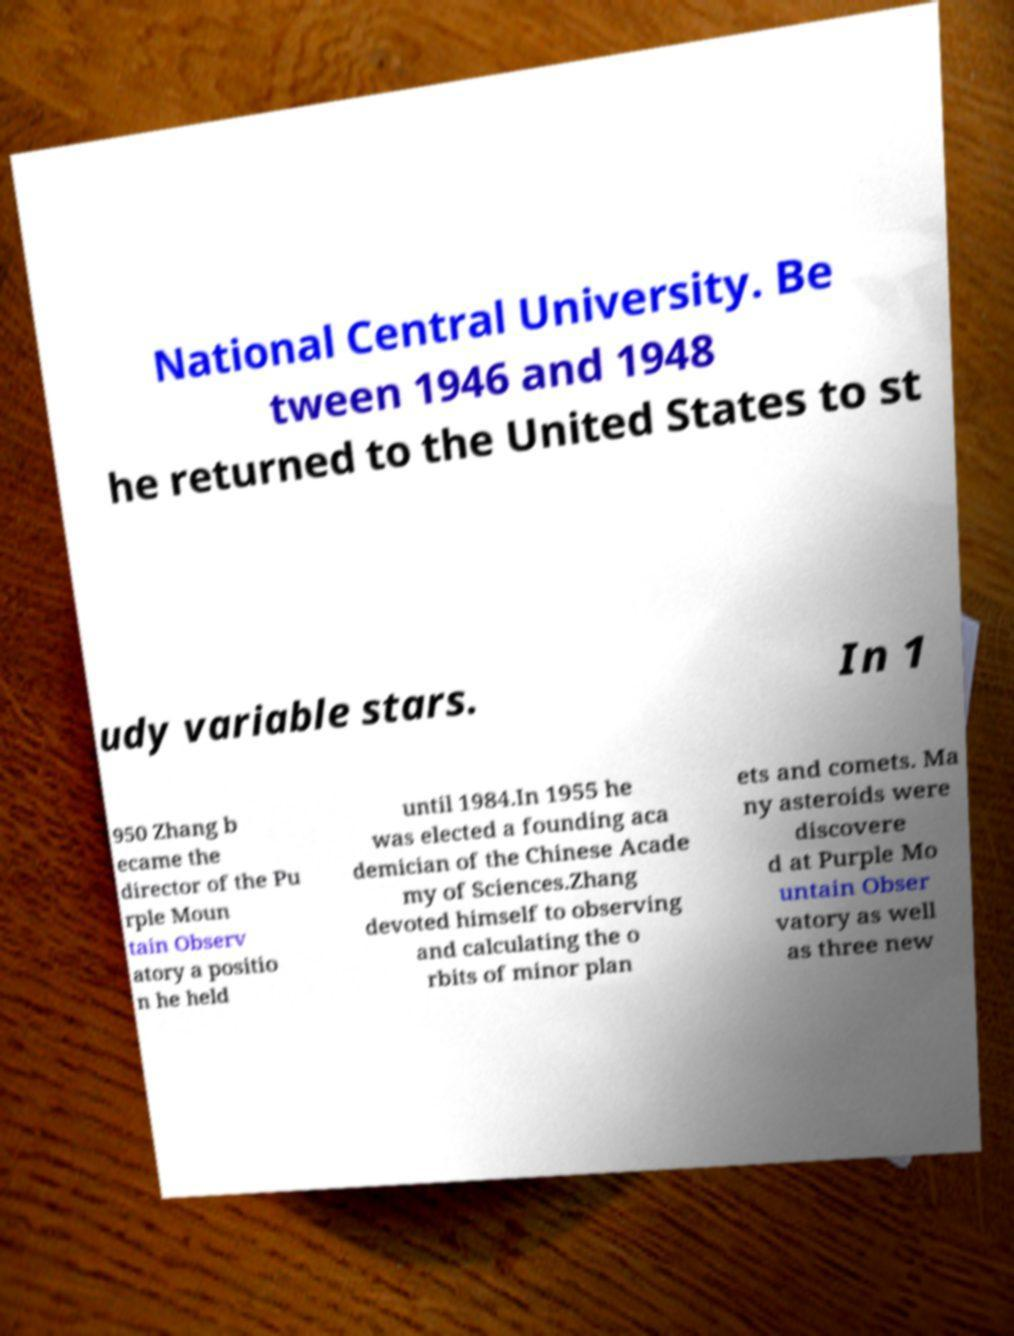Please read and relay the text visible in this image. What does it say? National Central University. Be tween 1946 and 1948 he returned to the United States to st udy variable stars. In 1 950 Zhang b ecame the director of the Pu rple Moun tain Observ atory a positio n he held until 1984.In 1955 he was elected a founding aca demician of the Chinese Acade my of Sciences.Zhang devoted himself to observing and calculating the o rbits of minor plan ets and comets. Ma ny asteroids were discovere d at Purple Mo untain Obser vatory as well as three new 